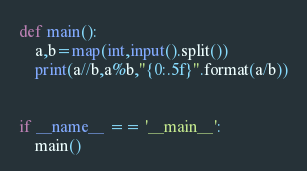<code> <loc_0><loc_0><loc_500><loc_500><_Python_>def main():
    a,b=map(int,input().split())
    print(a//b,a%b,"{0:.5f}".format(a/b))
 
 
if __name__ == '__main__':
    main()
</code> 